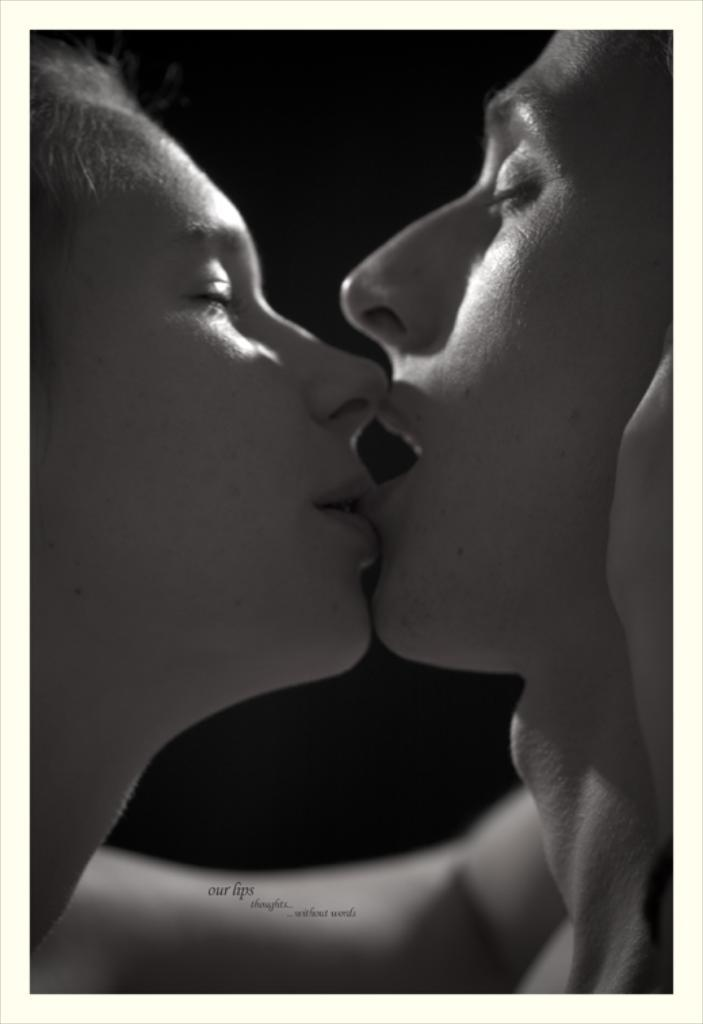How many people are present in the image? There are two people in the image. What can be seen in the background of the image? The background of the image is black. What type of vest is the person on the left side of the image wearing? There is no vest visible on the person on the left side of the image. What unit of measurement is being used to determine the distance between the two people in the image? There is no indication of any unit of measurement being used in the image. How many times are the two people in the image shaking hands? There is no indication of any handshake occurring between the two people in the image. 